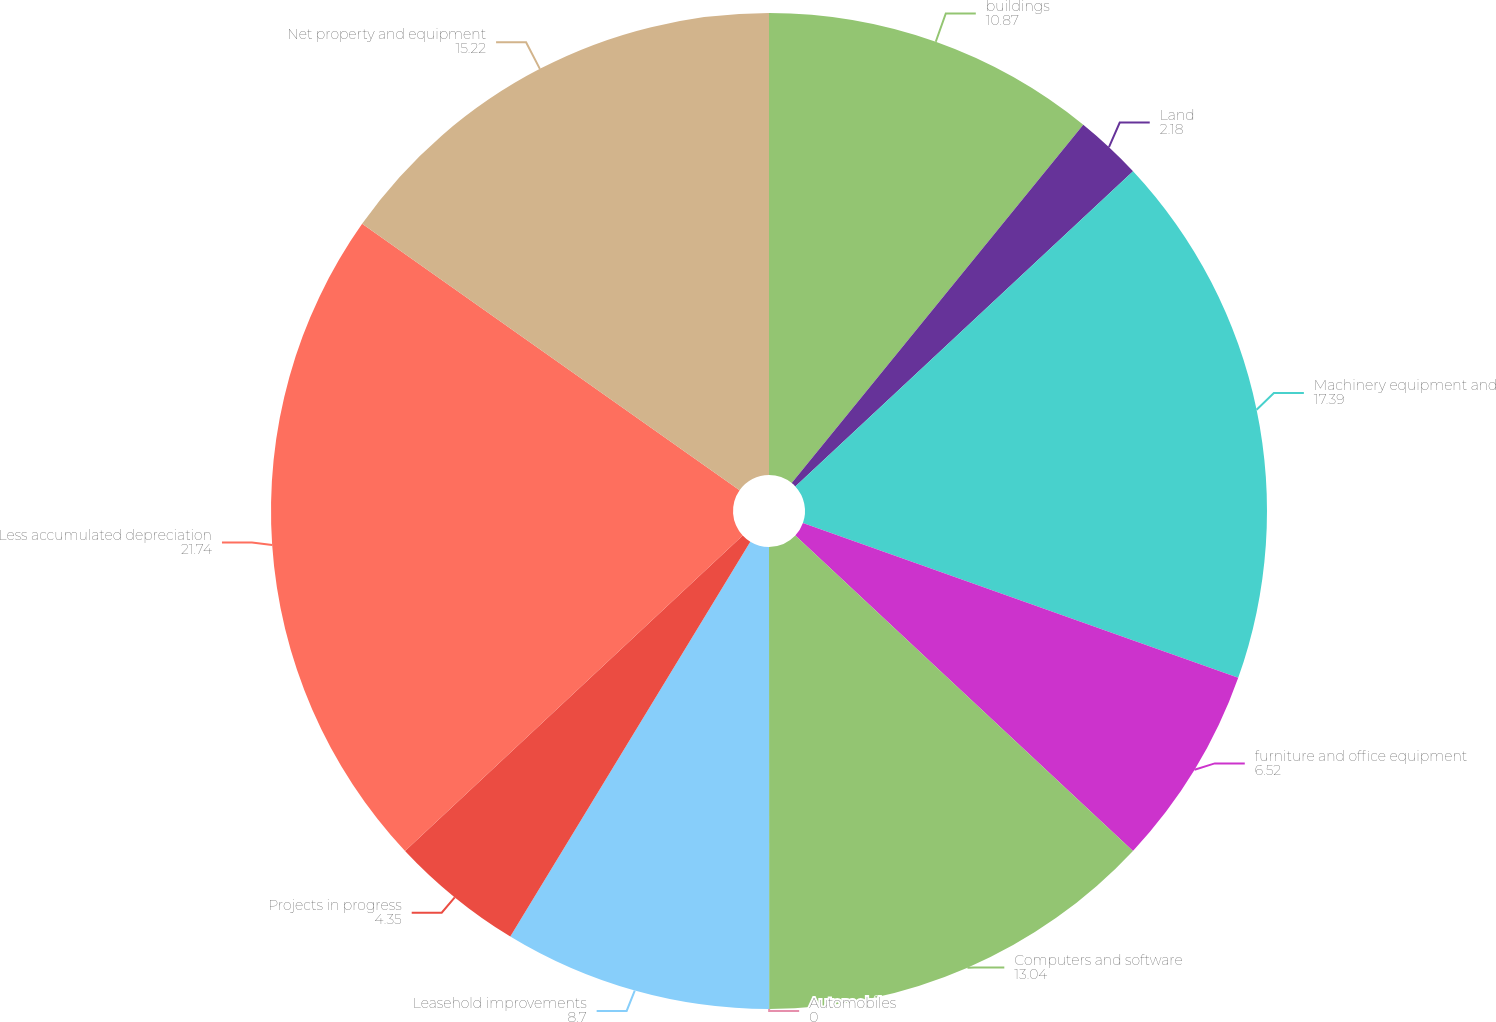Convert chart. <chart><loc_0><loc_0><loc_500><loc_500><pie_chart><fcel>buildings<fcel>Land<fcel>Machinery equipment and<fcel>furniture and office equipment<fcel>Computers and software<fcel>Automobiles<fcel>Leasehold improvements<fcel>Projects in progress<fcel>Less accumulated depreciation<fcel>Net property and equipment<nl><fcel>10.87%<fcel>2.18%<fcel>17.39%<fcel>6.52%<fcel>13.04%<fcel>0.0%<fcel>8.7%<fcel>4.35%<fcel>21.74%<fcel>15.22%<nl></chart> 